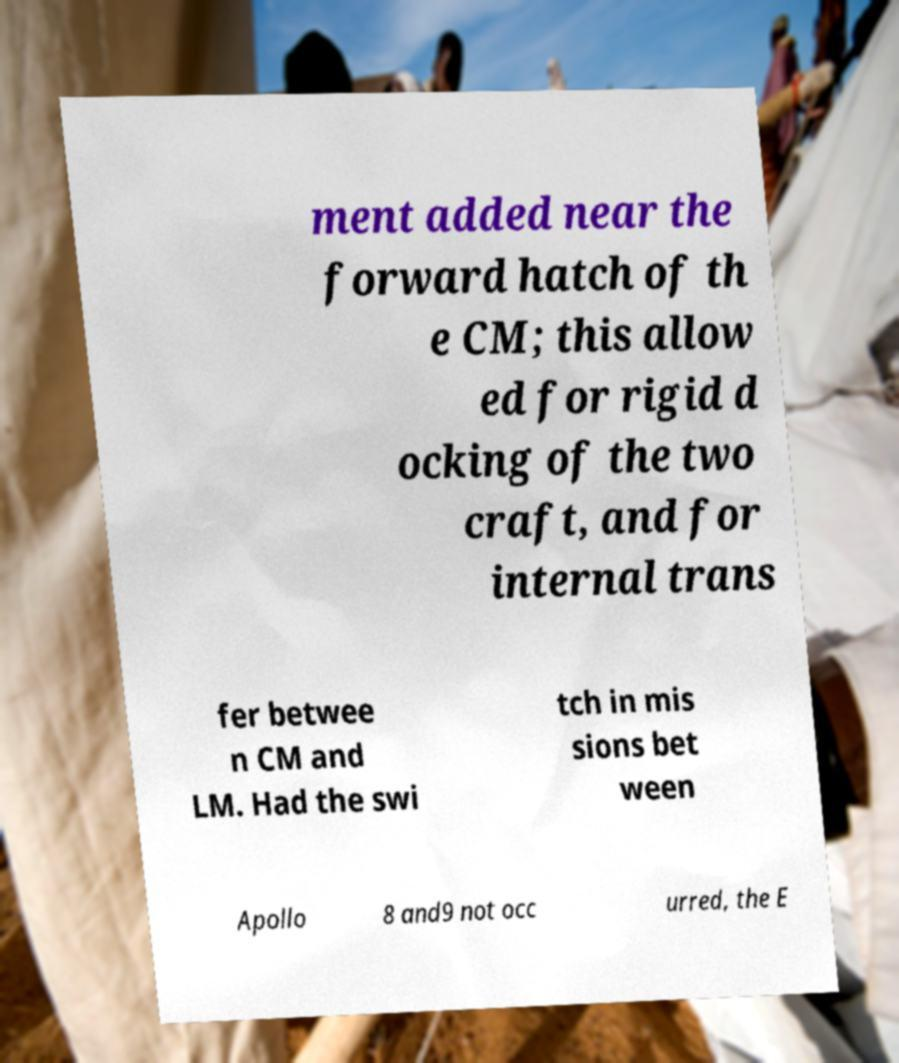Please read and relay the text visible in this image. What does it say? ment added near the forward hatch of th e CM; this allow ed for rigid d ocking of the two craft, and for internal trans fer betwee n CM and LM. Had the swi tch in mis sions bet ween Apollo 8 and9 not occ urred, the E 